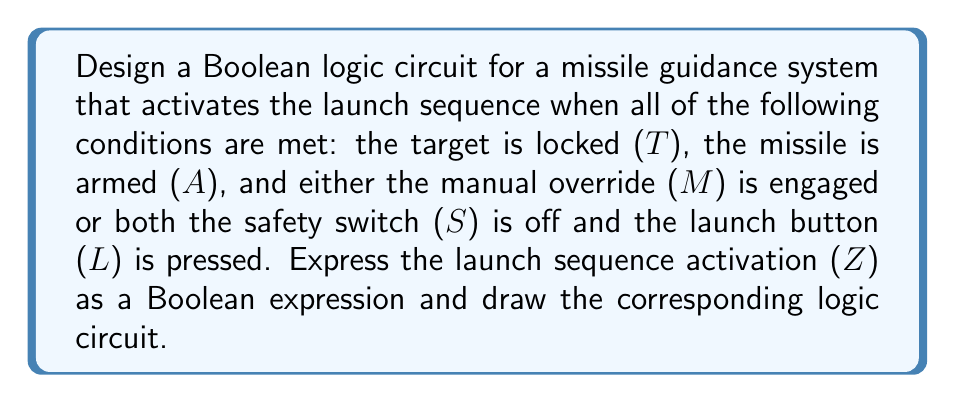Teach me how to tackle this problem. Let's approach this step-by-step:

1. Identify the variables:
   T: Target locked
   A: Missile armed
   M: Manual override
   S: Safety switch (off when 0)
   L: Launch button
   Z: Launch sequence activation

2. Analyze the conditions:
   - Target must be locked (T) AND
   - Missile must be armed (A) AND
   - Either:
     - Manual override is engaged (M) OR
     - Safety switch is off (NOT S) AND Launch button is pressed (L)

3. Construct the Boolean expression:
   $Z = T \cdot A \cdot (M + \overline{S} \cdot L)$

4. Simplify the expression (if possible):
   The expression is already in its simplest form.

5. Draw the logic circuit:

[asy]
import geometry;

pair A = (0,80), B = (0,60), C = (0,40), D = (0,20), E = (0,0);
pair F = (60,70), G = (60,30), H = (60,10);
pair I = (120,50), J = (180,40);

draw(A--F, arrow=Arrow(TeXHead));
draw(B--F, arrow=Arrow(TeXHead));
draw(C--G, arrow=Arrow(TeXHead));
draw(D--H, arrow=Arrow(TeXHead));
draw(E--H, arrow=Arrow(TeXHead));
draw(F--I, arrow=Arrow(TeXHead));
draw(G--I, arrow=Arrow(TeXHead));
draw(H--I, arrow=Arrow(TeXHead));
draw(I--J, arrow=Arrow(TeXHead));

label("T", A, W);
label("A", B, W);
label("M", C, W);
label("$\overline{S}$", D, W);
label("L", E, W);
label("AND", F, E);
label("OR", G, E);
label("AND", H, E);
label("AND", I, E);
label("Z", J, E);

draw(circle(F,10));
draw(circle(G,10));
draw(circle(H,10));
draw(circle(I,10));
[/asy]

This logic circuit represents the Boolean expression for the missile launch sequence activation.
Answer: $Z = T \cdot A \cdot (M + \overline{S} \cdot L)$ 